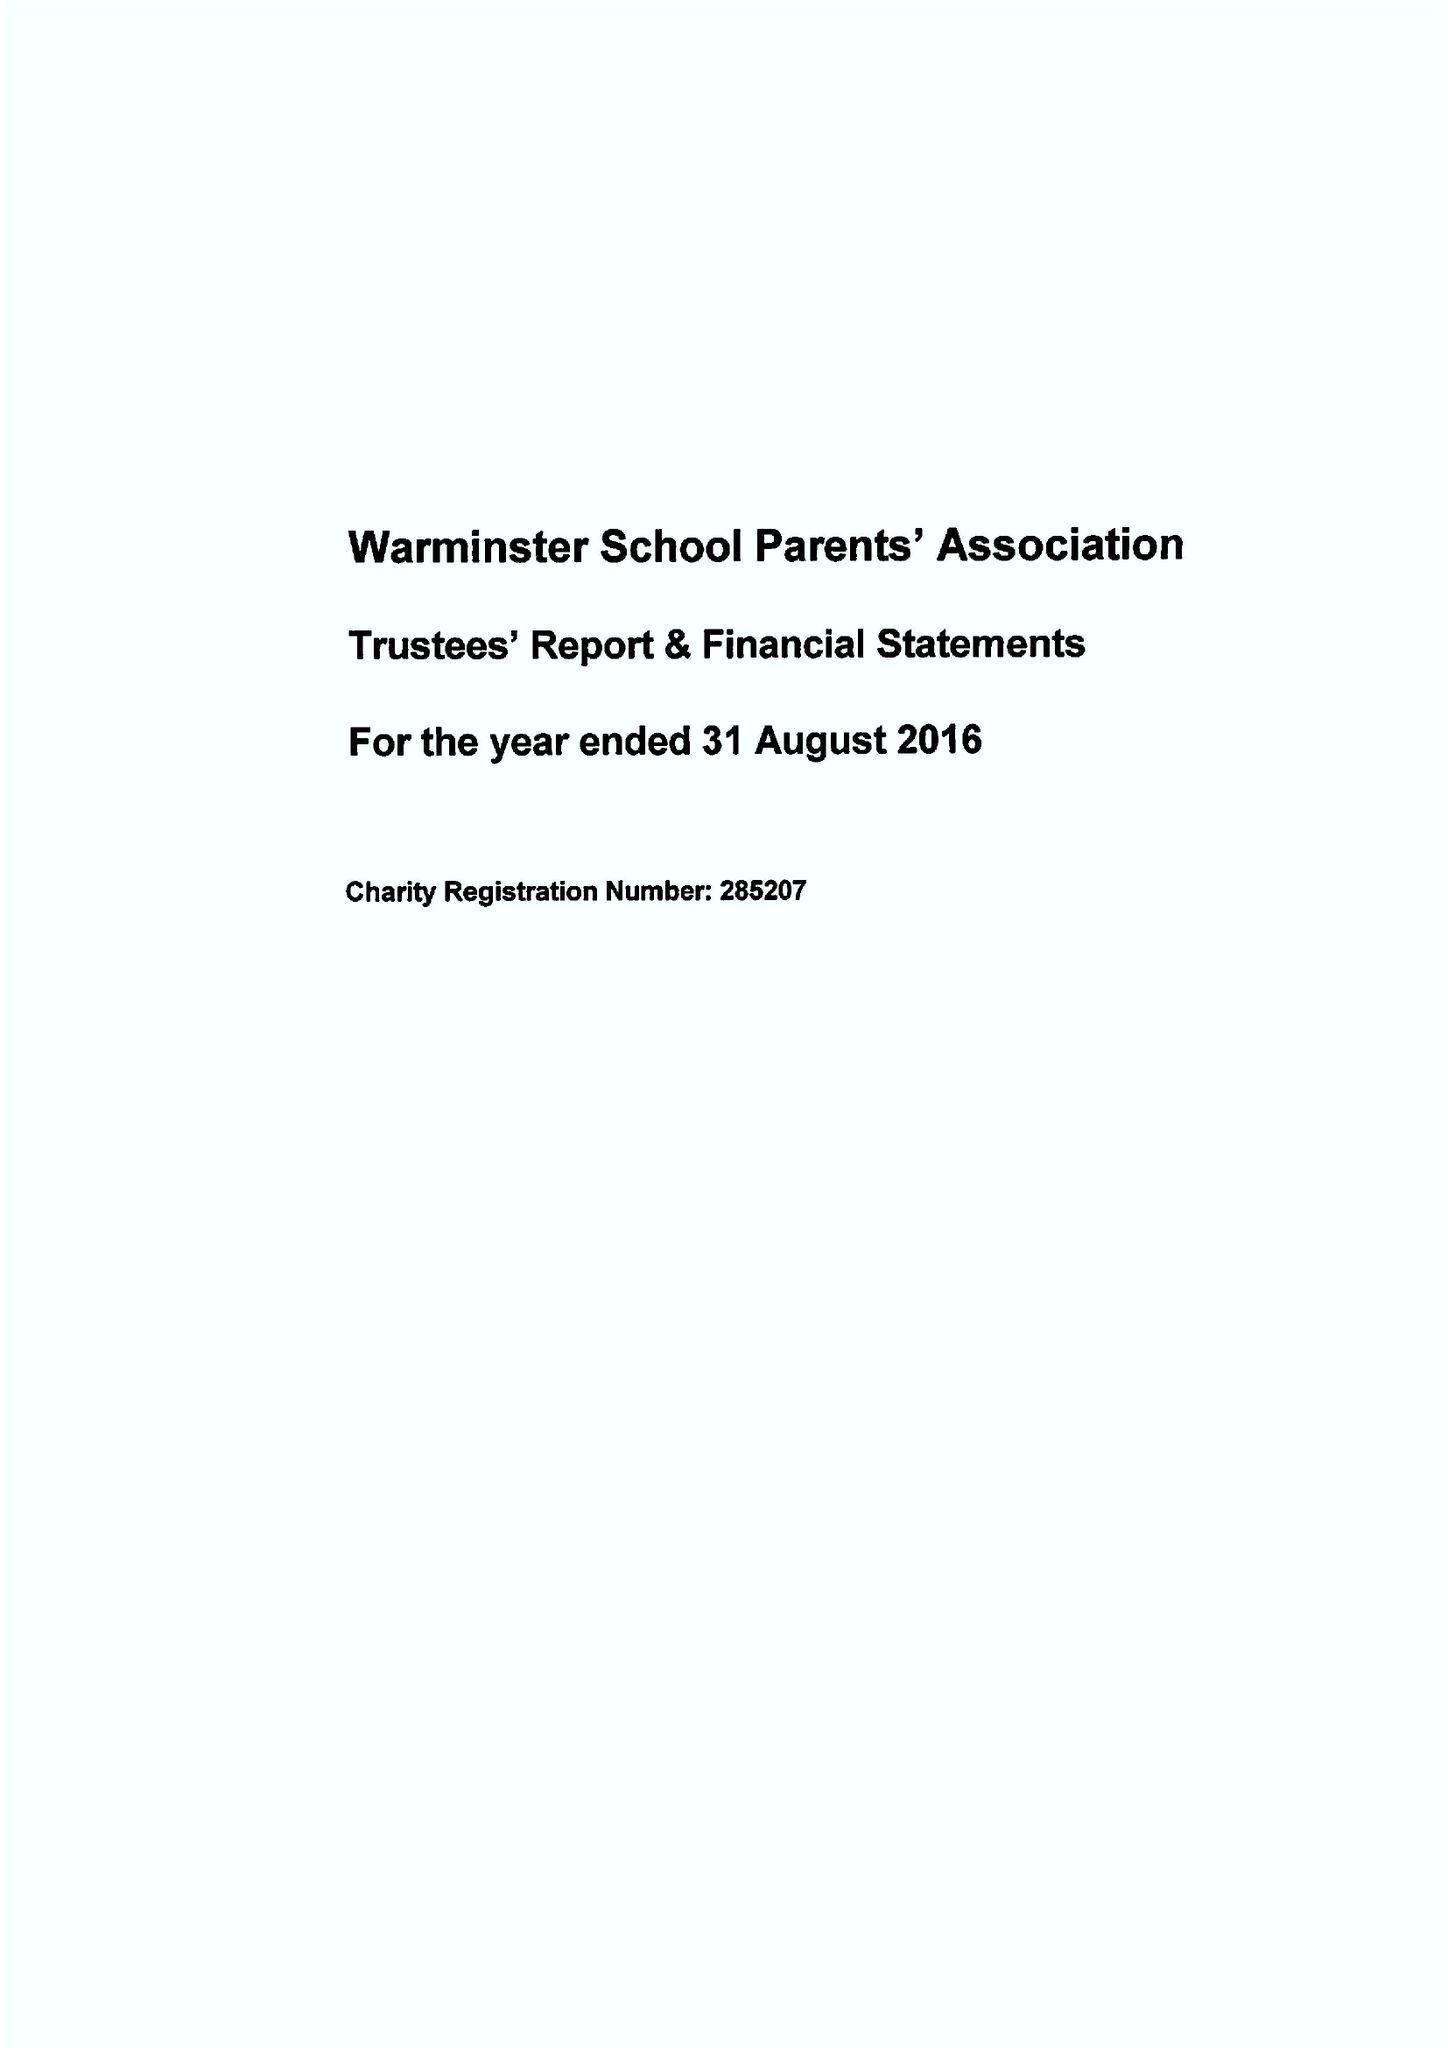What is the value for the charity_name?
Answer the question using a single word or phrase. Warminster School Parents' Association 